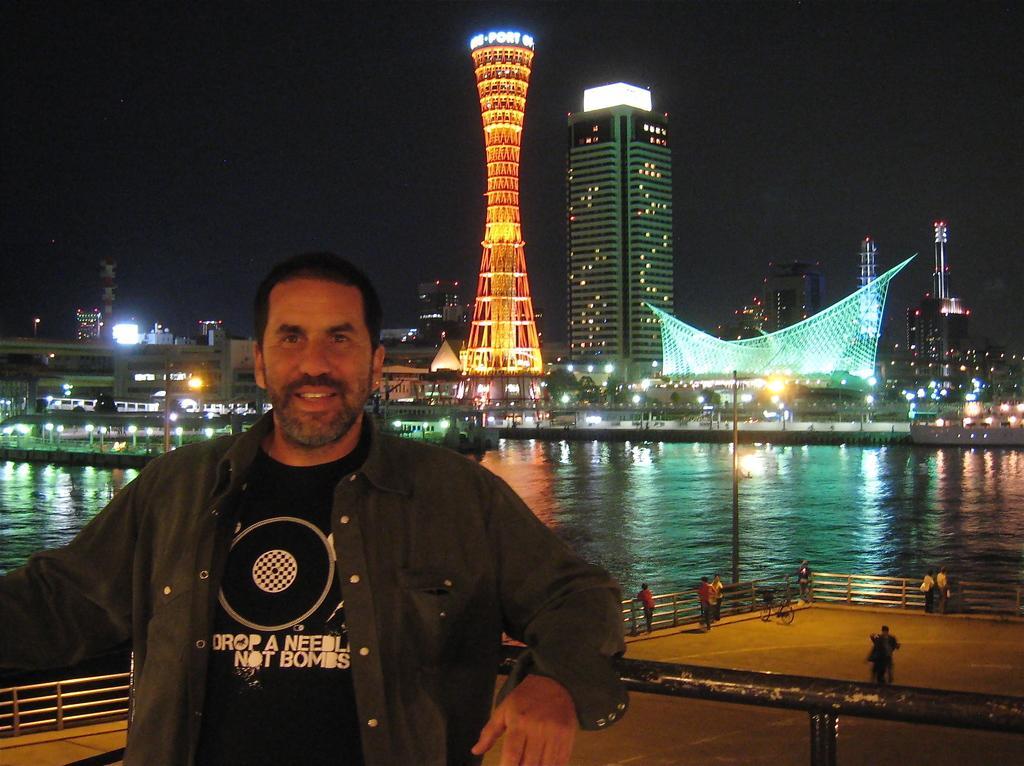Describe this image in one or two sentences. In this image we can see a man standing beside a fence. On the backside we can see a bicycle and a group of people on the deck. We can also see a group of buildings with lights, poles, a street lamp, some boats in a large water body and the sky. 